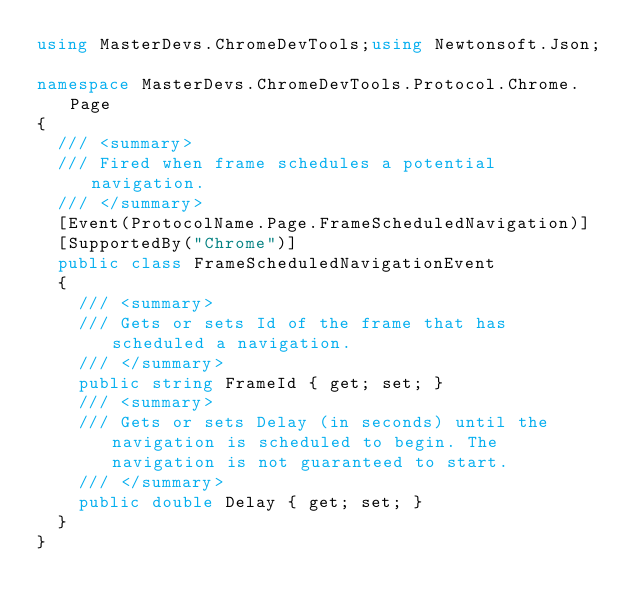<code> <loc_0><loc_0><loc_500><loc_500><_C#_>using MasterDevs.ChromeDevTools;using Newtonsoft.Json;

namespace MasterDevs.ChromeDevTools.Protocol.Chrome.Page
{
	/// <summary>
	/// Fired when frame schedules a potential navigation.
	/// </summary>
	[Event(ProtocolName.Page.FrameScheduledNavigation)]
	[SupportedBy("Chrome")]
	public class FrameScheduledNavigationEvent
	{
		/// <summary>
		/// Gets or sets Id of the frame that has scheduled a navigation.
		/// </summary>
		public string FrameId { get; set; }
		/// <summary>
		/// Gets or sets Delay (in seconds) until the navigation is scheduled to begin. The navigation is not guaranteed to start.
		/// </summary>
		public double Delay { get; set; }
	}
}
</code> 